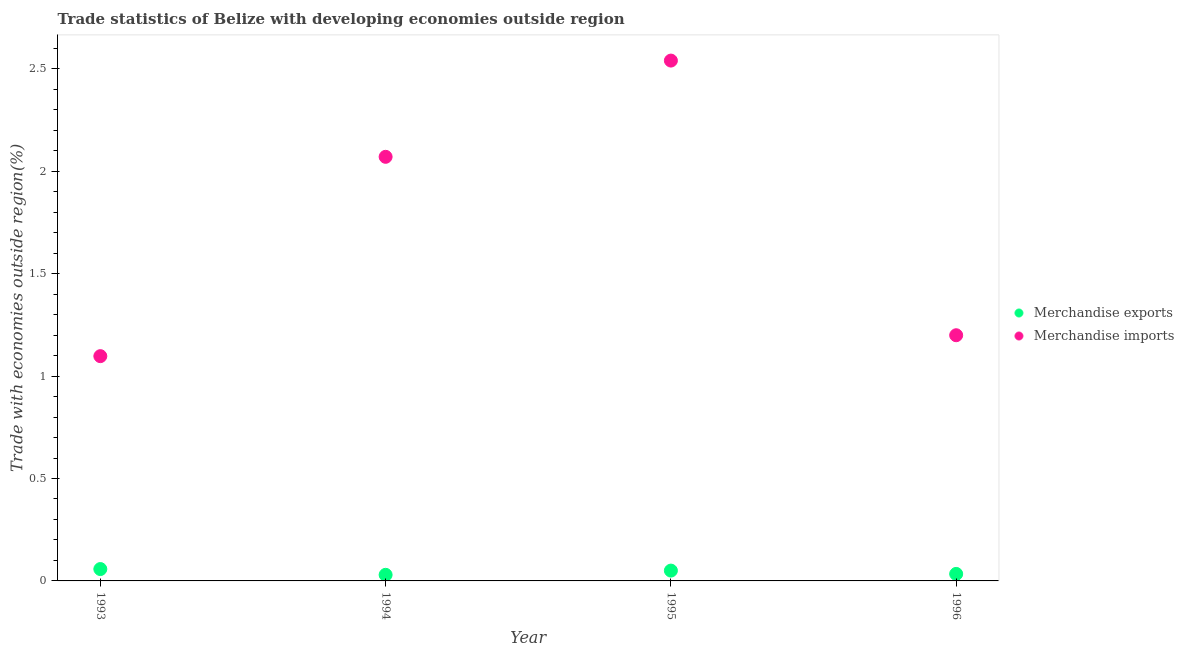Is the number of dotlines equal to the number of legend labels?
Offer a very short reply. Yes. What is the merchandise imports in 1994?
Your answer should be very brief. 2.07. Across all years, what is the maximum merchandise exports?
Your response must be concise. 0.06. Across all years, what is the minimum merchandise imports?
Offer a terse response. 1.1. In which year was the merchandise exports maximum?
Keep it short and to the point. 1993. In which year was the merchandise imports minimum?
Provide a short and direct response. 1993. What is the total merchandise exports in the graph?
Offer a very short reply. 0.17. What is the difference between the merchandise imports in 1993 and that in 1995?
Provide a short and direct response. -1.44. What is the difference between the merchandise imports in 1993 and the merchandise exports in 1995?
Offer a terse response. 1.05. What is the average merchandise exports per year?
Give a very brief answer. 0.04. In the year 1995, what is the difference between the merchandise imports and merchandise exports?
Your answer should be very brief. 2.49. What is the ratio of the merchandise exports in 1993 to that in 1994?
Offer a terse response. 1.95. Is the difference between the merchandise exports in 1994 and 1995 greater than the difference between the merchandise imports in 1994 and 1995?
Your answer should be compact. Yes. What is the difference between the highest and the second highest merchandise exports?
Make the answer very short. 0.01. What is the difference between the highest and the lowest merchandise exports?
Keep it short and to the point. 0.03. Does the merchandise exports monotonically increase over the years?
Ensure brevity in your answer.  No. Is the merchandise exports strictly greater than the merchandise imports over the years?
Offer a terse response. No. Is the merchandise exports strictly less than the merchandise imports over the years?
Give a very brief answer. Yes. What is the difference between two consecutive major ticks on the Y-axis?
Ensure brevity in your answer.  0.5. Are the values on the major ticks of Y-axis written in scientific E-notation?
Provide a succinct answer. No. Does the graph contain any zero values?
Keep it short and to the point. No. Does the graph contain grids?
Provide a short and direct response. No. Where does the legend appear in the graph?
Ensure brevity in your answer.  Center right. How many legend labels are there?
Make the answer very short. 2. How are the legend labels stacked?
Give a very brief answer. Vertical. What is the title of the graph?
Your response must be concise. Trade statistics of Belize with developing economies outside region. Does "Ages 15-24" appear as one of the legend labels in the graph?
Your response must be concise. No. What is the label or title of the X-axis?
Provide a short and direct response. Year. What is the label or title of the Y-axis?
Provide a succinct answer. Trade with economies outside region(%). What is the Trade with economies outside region(%) of Merchandise exports in 1993?
Keep it short and to the point. 0.06. What is the Trade with economies outside region(%) in Merchandise imports in 1993?
Offer a very short reply. 1.1. What is the Trade with economies outside region(%) of Merchandise exports in 1994?
Ensure brevity in your answer.  0.03. What is the Trade with economies outside region(%) of Merchandise imports in 1994?
Offer a terse response. 2.07. What is the Trade with economies outside region(%) in Merchandise exports in 1995?
Ensure brevity in your answer.  0.05. What is the Trade with economies outside region(%) of Merchandise imports in 1995?
Your response must be concise. 2.54. What is the Trade with economies outside region(%) of Merchandise exports in 1996?
Your answer should be very brief. 0.03. What is the Trade with economies outside region(%) of Merchandise imports in 1996?
Your response must be concise. 1.2. Across all years, what is the maximum Trade with economies outside region(%) in Merchandise exports?
Ensure brevity in your answer.  0.06. Across all years, what is the maximum Trade with economies outside region(%) in Merchandise imports?
Ensure brevity in your answer.  2.54. Across all years, what is the minimum Trade with economies outside region(%) of Merchandise exports?
Provide a short and direct response. 0.03. Across all years, what is the minimum Trade with economies outside region(%) in Merchandise imports?
Ensure brevity in your answer.  1.1. What is the total Trade with economies outside region(%) in Merchandise exports in the graph?
Provide a succinct answer. 0.17. What is the total Trade with economies outside region(%) of Merchandise imports in the graph?
Keep it short and to the point. 6.91. What is the difference between the Trade with economies outside region(%) of Merchandise exports in 1993 and that in 1994?
Your response must be concise. 0.03. What is the difference between the Trade with economies outside region(%) in Merchandise imports in 1993 and that in 1994?
Keep it short and to the point. -0.97. What is the difference between the Trade with economies outside region(%) in Merchandise exports in 1993 and that in 1995?
Your answer should be very brief. 0.01. What is the difference between the Trade with economies outside region(%) of Merchandise imports in 1993 and that in 1995?
Ensure brevity in your answer.  -1.44. What is the difference between the Trade with economies outside region(%) of Merchandise exports in 1993 and that in 1996?
Ensure brevity in your answer.  0.02. What is the difference between the Trade with economies outside region(%) in Merchandise imports in 1993 and that in 1996?
Keep it short and to the point. -0.1. What is the difference between the Trade with economies outside region(%) in Merchandise exports in 1994 and that in 1995?
Give a very brief answer. -0.02. What is the difference between the Trade with economies outside region(%) in Merchandise imports in 1994 and that in 1995?
Provide a succinct answer. -0.47. What is the difference between the Trade with economies outside region(%) in Merchandise exports in 1994 and that in 1996?
Offer a terse response. -0. What is the difference between the Trade with economies outside region(%) in Merchandise imports in 1994 and that in 1996?
Your answer should be compact. 0.87. What is the difference between the Trade with economies outside region(%) of Merchandise exports in 1995 and that in 1996?
Offer a terse response. 0.02. What is the difference between the Trade with economies outside region(%) in Merchandise imports in 1995 and that in 1996?
Your response must be concise. 1.34. What is the difference between the Trade with economies outside region(%) in Merchandise exports in 1993 and the Trade with economies outside region(%) in Merchandise imports in 1994?
Ensure brevity in your answer.  -2.01. What is the difference between the Trade with economies outside region(%) of Merchandise exports in 1993 and the Trade with economies outside region(%) of Merchandise imports in 1995?
Your response must be concise. -2.48. What is the difference between the Trade with economies outside region(%) in Merchandise exports in 1993 and the Trade with economies outside region(%) in Merchandise imports in 1996?
Offer a terse response. -1.14. What is the difference between the Trade with economies outside region(%) in Merchandise exports in 1994 and the Trade with economies outside region(%) in Merchandise imports in 1995?
Provide a succinct answer. -2.51. What is the difference between the Trade with economies outside region(%) of Merchandise exports in 1994 and the Trade with economies outside region(%) of Merchandise imports in 1996?
Make the answer very short. -1.17. What is the difference between the Trade with economies outside region(%) of Merchandise exports in 1995 and the Trade with economies outside region(%) of Merchandise imports in 1996?
Give a very brief answer. -1.15. What is the average Trade with economies outside region(%) of Merchandise exports per year?
Give a very brief answer. 0.04. What is the average Trade with economies outside region(%) in Merchandise imports per year?
Ensure brevity in your answer.  1.73. In the year 1993, what is the difference between the Trade with economies outside region(%) in Merchandise exports and Trade with economies outside region(%) in Merchandise imports?
Provide a short and direct response. -1.04. In the year 1994, what is the difference between the Trade with economies outside region(%) in Merchandise exports and Trade with economies outside region(%) in Merchandise imports?
Offer a very short reply. -2.04. In the year 1995, what is the difference between the Trade with economies outside region(%) in Merchandise exports and Trade with economies outside region(%) in Merchandise imports?
Offer a terse response. -2.49. In the year 1996, what is the difference between the Trade with economies outside region(%) in Merchandise exports and Trade with economies outside region(%) in Merchandise imports?
Your response must be concise. -1.17. What is the ratio of the Trade with economies outside region(%) in Merchandise exports in 1993 to that in 1994?
Your answer should be compact. 1.95. What is the ratio of the Trade with economies outside region(%) in Merchandise imports in 1993 to that in 1994?
Give a very brief answer. 0.53. What is the ratio of the Trade with economies outside region(%) of Merchandise exports in 1993 to that in 1995?
Your response must be concise. 1.15. What is the ratio of the Trade with economies outside region(%) in Merchandise imports in 1993 to that in 1995?
Keep it short and to the point. 0.43. What is the ratio of the Trade with economies outside region(%) in Merchandise exports in 1993 to that in 1996?
Ensure brevity in your answer.  1.69. What is the ratio of the Trade with economies outside region(%) of Merchandise imports in 1993 to that in 1996?
Offer a very short reply. 0.91. What is the ratio of the Trade with economies outside region(%) in Merchandise exports in 1994 to that in 1995?
Provide a succinct answer. 0.59. What is the ratio of the Trade with economies outside region(%) of Merchandise imports in 1994 to that in 1995?
Your response must be concise. 0.82. What is the ratio of the Trade with economies outside region(%) in Merchandise exports in 1994 to that in 1996?
Offer a very short reply. 0.87. What is the ratio of the Trade with economies outside region(%) of Merchandise imports in 1994 to that in 1996?
Your response must be concise. 1.73. What is the ratio of the Trade with economies outside region(%) of Merchandise exports in 1995 to that in 1996?
Give a very brief answer. 1.47. What is the ratio of the Trade with economies outside region(%) of Merchandise imports in 1995 to that in 1996?
Offer a very short reply. 2.12. What is the difference between the highest and the second highest Trade with economies outside region(%) of Merchandise exports?
Provide a succinct answer. 0.01. What is the difference between the highest and the second highest Trade with economies outside region(%) in Merchandise imports?
Your answer should be compact. 0.47. What is the difference between the highest and the lowest Trade with economies outside region(%) of Merchandise exports?
Make the answer very short. 0.03. What is the difference between the highest and the lowest Trade with economies outside region(%) of Merchandise imports?
Provide a short and direct response. 1.44. 